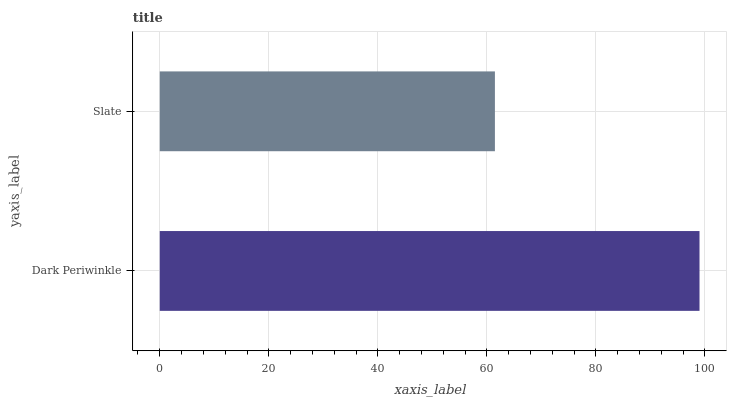Is Slate the minimum?
Answer yes or no. Yes. Is Dark Periwinkle the maximum?
Answer yes or no. Yes. Is Slate the maximum?
Answer yes or no. No. Is Dark Periwinkle greater than Slate?
Answer yes or no. Yes. Is Slate less than Dark Periwinkle?
Answer yes or no. Yes. Is Slate greater than Dark Periwinkle?
Answer yes or no. No. Is Dark Periwinkle less than Slate?
Answer yes or no. No. Is Dark Periwinkle the high median?
Answer yes or no. Yes. Is Slate the low median?
Answer yes or no. Yes. Is Slate the high median?
Answer yes or no. No. Is Dark Periwinkle the low median?
Answer yes or no. No. 